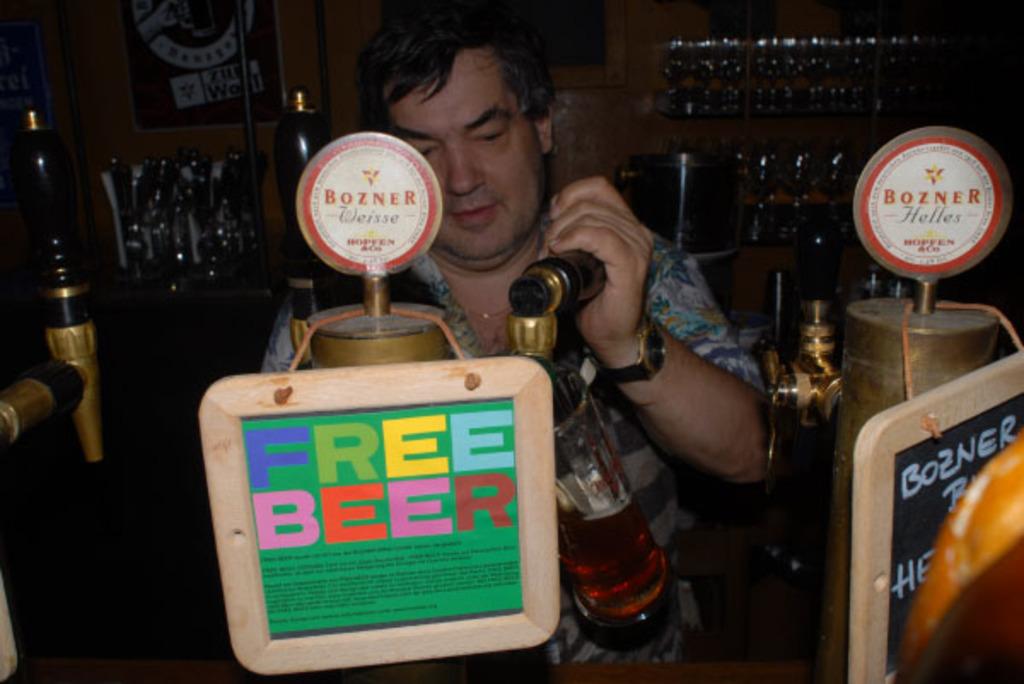What brand of beer is on tap?
Your answer should be compact. Bozner. 